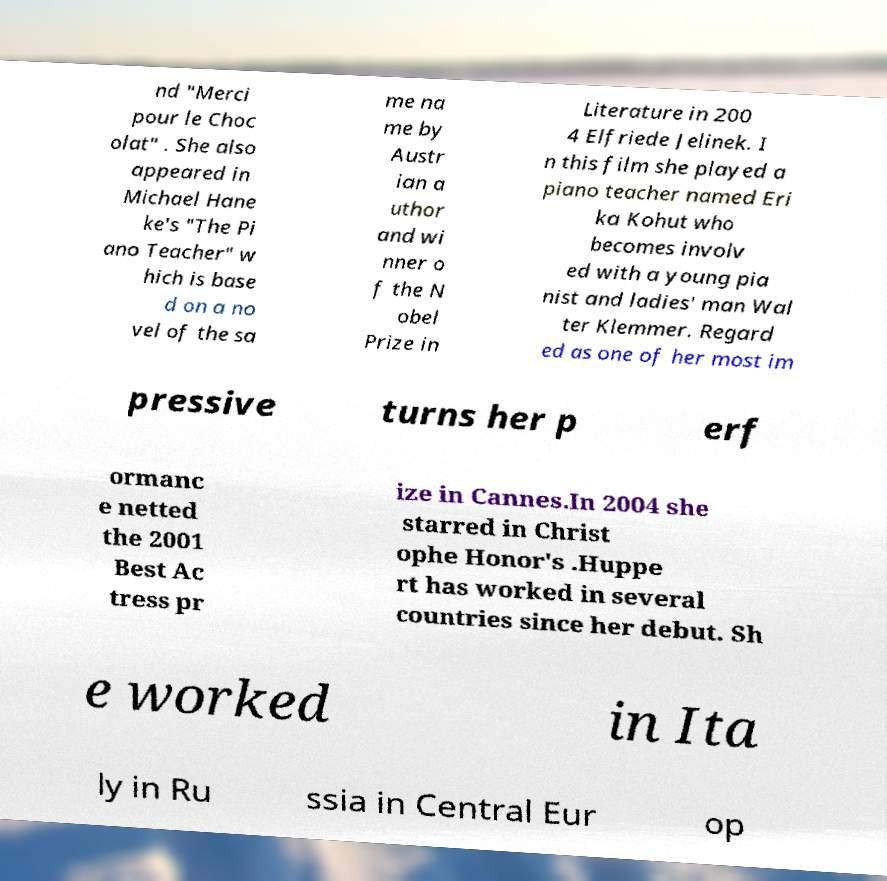Please read and relay the text visible in this image. What does it say? nd "Merci pour le Choc olat" . She also appeared in Michael Hane ke's "The Pi ano Teacher" w hich is base d on a no vel of the sa me na me by Austr ian a uthor and wi nner o f the N obel Prize in Literature in 200 4 Elfriede Jelinek. I n this film she played a piano teacher named Eri ka Kohut who becomes involv ed with a young pia nist and ladies' man Wal ter Klemmer. Regard ed as one of her most im pressive turns her p erf ormanc e netted the 2001 Best Ac tress pr ize in Cannes.In 2004 she starred in Christ ophe Honor's .Huppe rt has worked in several countries since her debut. Sh e worked in Ita ly in Ru ssia in Central Eur op 